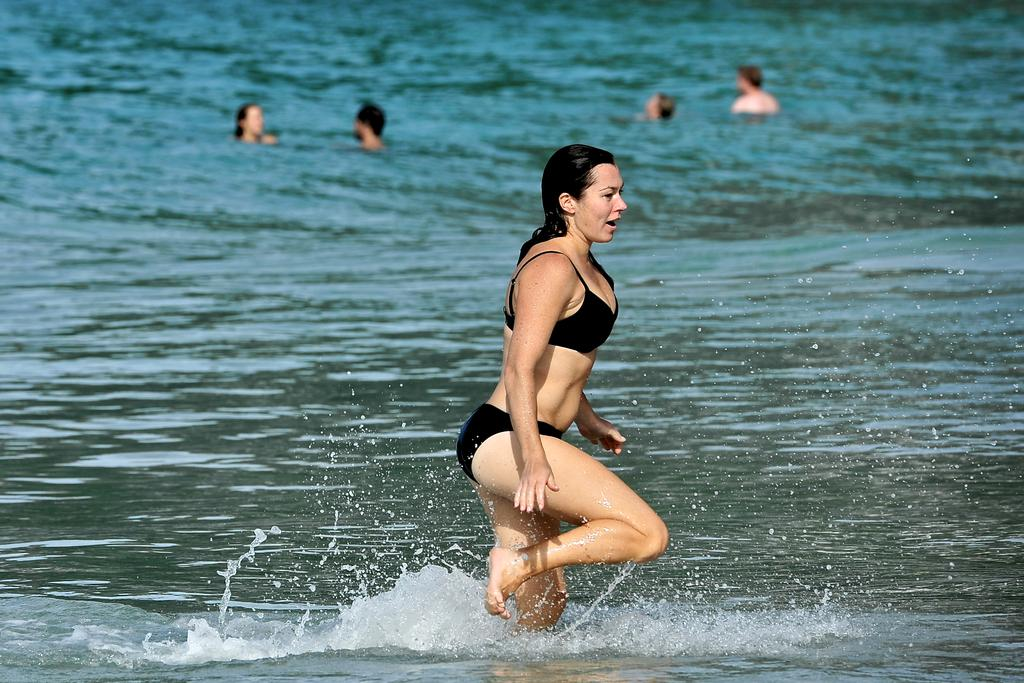What is the main subject of the image? There is a woman in the water in the center of the image. How is the background of the image depicted? The background is blurred. What are the people in the image doing? There are people swimming in the background. What type of location is shown in the image? There is a water body in the image. What type of knee injury can be seen in the image? There is no knee injury present in the image; it features a woman in the water and people swimming in the background. What type of sponge is being used for cleaning in the image? There is no sponge present in the image. 